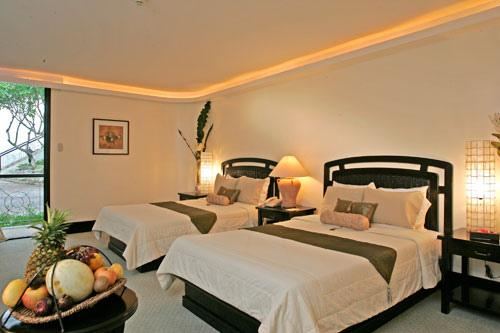What is the most likely level of this room? Please explain your reasoning. ground. One can see the pavement outside which is the same level as the bedroom 